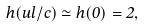Convert formula to latex. <formula><loc_0><loc_0><loc_500><loc_500>h ( u l / c ) \simeq h ( 0 ) = 2 ,</formula> 